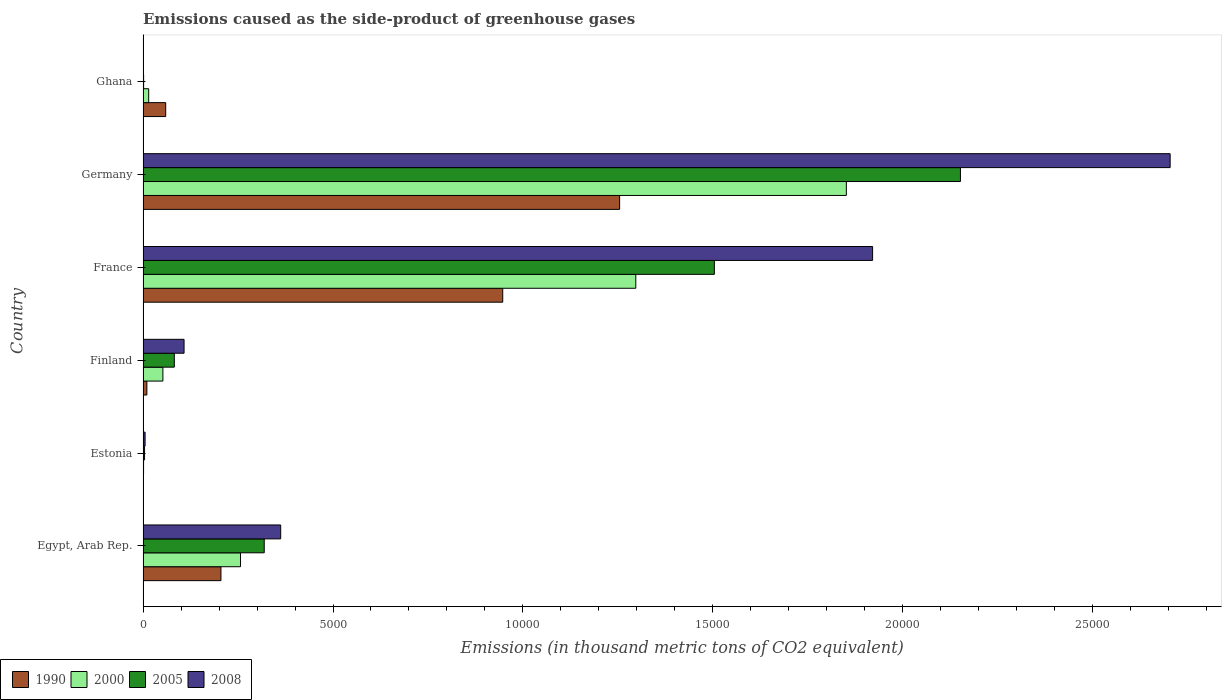Are the number of bars per tick equal to the number of legend labels?
Provide a short and direct response. Yes. How many bars are there on the 2nd tick from the bottom?
Offer a terse response. 4. In how many cases, is the number of bars for a given country not equal to the number of legend labels?
Provide a succinct answer. 0. What is the emissions caused as the side-product of greenhouse gases in 2000 in Ghana?
Your answer should be compact. 148. Across all countries, what is the maximum emissions caused as the side-product of greenhouse gases in 2000?
Your answer should be compact. 1.85e+04. Across all countries, what is the minimum emissions caused as the side-product of greenhouse gases in 1990?
Make the answer very short. 2.1. In which country was the emissions caused as the side-product of greenhouse gases in 2008 maximum?
Give a very brief answer. Germany. In which country was the emissions caused as the side-product of greenhouse gases in 2008 minimum?
Offer a terse response. Ghana. What is the total emissions caused as the side-product of greenhouse gases in 2000 in the graph?
Keep it short and to the point. 3.47e+04. What is the difference between the emissions caused as the side-product of greenhouse gases in 2005 in Estonia and that in Germany?
Offer a terse response. -2.15e+04. What is the difference between the emissions caused as the side-product of greenhouse gases in 2005 in Ghana and the emissions caused as the side-product of greenhouse gases in 2000 in France?
Your response must be concise. -1.30e+04. What is the average emissions caused as the side-product of greenhouse gases in 2008 per country?
Ensure brevity in your answer.  8501.6. What is the difference between the emissions caused as the side-product of greenhouse gases in 1990 and emissions caused as the side-product of greenhouse gases in 2000 in Germany?
Your answer should be very brief. -5968.2. What is the ratio of the emissions caused as the side-product of greenhouse gases in 2000 in Egypt, Arab Rep. to that in France?
Offer a very short reply. 0.2. Is the difference between the emissions caused as the side-product of greenhouse gases in 1990 in Finland and Ghana greater than the difference between the emissions caused as the side-product of greenhouse gases in 2000 in Finland and Ghana?
Your answer should be very brief. No. What is the difference between the highest and the second highest emissions caused as the side-product of greenhouse gases in 2008?
Your answer should be very brief. 7832.8. What is the difference between the highest and the lowest emissions caused as the side-product of greenhouse gases in 2005?
Offer a very short reply. 2.15e+04. In how many countries, is the emissions caused as the side-product of greenhouse gases in 1990 greater than the average emissions caused as the side-product of greenhouse gases in 1990 taken over all countries?
Your answer should be very brief. 2. Is the sum of the emissions caused as the side-product of greenhouse gases in 2008 in Egypt, Arab Rep. and France greater than the maximum emissions caused as the side-product of greenhouse gases in 2005 across all countries?
Your response must be concise. Yes. Is it the case that in every country, the sum of the emissions caused as the side-product of greenhouse gases in 1990 and emissions caused as the side-product of greenhouse gases in 2008 is greater than the sum of emissions caused as the side-product of greenhouse gases in 2000 and emissions caused as the side-product of greenhouse gases in 2005?
Provide a short and direct response. No. What does the 1st bar from the bottom in Ghana represents?
Offer a terse response. 1990. Is it the case that in every country, the sum of the emissions caused as the side-product of greenhouse gases in 2008 and emissions caused as the side-product of greenhouse gases in 2005 is greater than the emissions caused as the side-product of greenhouse gases in 2000?
Give a very brief answer. No. How many bars are there?
Your answer should be compact. 24. Are all the bars in the graph horizontal?
Keep it short and to the point. Yes. What is the difference between two consecutive major ticks on the X-axis?
Offer a terse response. 5000. Are the values on the major ticks of X-axis written in scientific E-notation?
Make the answer very short. No. Does the graph contain grids?
Your response must be concise. No. How many legend labels are there?
Your answer should be very brief. 4. How are the legend labels stacked?
Keep it short and to the point. Horizontal. What is the title of the graph?
Keep it short and to the point. Emissions caused as the side-product of greenhouse gases. What is the label or title of the X-axis?
Your response must be concise. Emissions (in thousand metric tons of CO2 equivalent). What is the label or title of the Y-axis?
Offer a terse response. Country. What is the Emissions (in thousand metric tons of CO2 equivalent) in 1990 in Egypt, Arab Rep.?
Your answer should be very brief. 2050.5. What is the Emissions (in thousand metric tons of CO2 equivalent) of 2000 in Egypt, Arab Rep.?
Your response must be concise. 2565.6. What is the Emissions (in thousand metric tons of CO2 equivalent) of 2005 in Egypt, Arab Rep.?
Keep it short and to the point. 3189.8. What is the Emissions (in thousand metric tons of CO2 equivalent) in 2008 in Egypt, Arab Rep.?
Ensure brevity in your answer.  3622.8. What is the Emissions (in thousand metric tons of CO2 equivalent) of 2000 in Estonia?
Your answer should be very brief. 13.3. What is the Emissions (in thousand metric tons of CO2 equivalent) in 2005 in Estonia?
Give a very brief answer. 39.4. What is the Emissions (in thousand metric tons of CO2 equivalent) of 2008 in Estonia?
Give a very brief answer. 53.3. What is the Emissions (in thousand metric tons of CO2 equivalent) in 1990 in Finland?
Give a very brief answer. 100.2. What is the Emissions (in thousand metric tons of CO2 equivalent) in 2000 in Finland?
Give a very brief answer. 521.8. What is the Emissions (in thousand metric tons of CO2 equivalent) in 2005 in Finland?
Provide a succinct answer. 822.5. What is the Emissions (in thousand metric tons of CO2 equivalent) in 2008 in Finland?
Provide a succinct answer. 1079.5. What is the Emissions (in thousand metric tons of CO2 equivalent) in 1990 in France?
Provide a succinct answer. 9468.2. What is the Emissions (in thousand metric tons of CO2 equivalent) in 2000 in France?
Keep it short and to the point. 1.30e+04. What is the Emissions (in thousand metric tons of CO2 equivalent) of 2005 in France?
Give a very brief answer. 1.50e+04. What is the Emissions (in thousand metric tons of CO2 equivalent) of 2008 in France?
Give a very brief answer. 1.92e+04. What is the Emissions (in thousand metric tons of CO2 equivalent) in 1990 in Germany?
Your answer should be compact. 1.25e+04. What is the Emissions (in thousand metric tons of CO2 equivalent) of 2000 in Germany?
Give a very brief answer. 1.85e+04. What is the Emissions (in thousand metric tons of CO2 equivalent) in 2005 in Germany?
Keep it short and to the point. 2.15e+04. What is the Emissions (in thousand metric tons of CO2 equivalent) of 2008 in Germany?
Keep it short and to the point. 2.70e+04. What is the Emissions (in thousand metric tons of CO2 equivalent) in 1990 in Ghana?
Provide a short and direct response. 596.2. What is the Emissions (in thousand metric tons of CO2 equivalent) of 2000 in Ghana?
Keep it short and to the point. 148. What is the Emissions (in thousand metric tons of CO2 equivalent) of 2008 in Ghana?
Offer a very short reply. 11.2. Across all countries, what is the maximum Emissions (in thousand metric tons of CO2 equivalent) in 1990?
Make the answer very short. 1.25e+04. Across all countries, what is the maximum Emissions (in thousand metric tons of CO2 equivalent) of 2000?
Keep it short and to the point. 1.85e+04. Across all countries, what is the maximum Emissions (in thousand metric tons of CO2 equivalent) of 2005?
Keep it short and to the point. 2.15e+04. Across all countries, what is the maximum Emissions (in thousand metric tons of CO2 equivalent) in 2008?
Keep it short and to the point. 2.70e+04. Across all countries, what is the minimum Emissions (in thousand metric tons of CO2 equivalent) of 2000?
Your answer should be very brief. 13.3. Across all countries, what is the minimum Emissions (in thousand metric tons of CO2 equivalent) of 2005?
Give a very brief answer. 14.7. Across all countries, what is the minimum Emissions (in thousand metric tons of CO2 equivalent) of 2008?
Give a very brief answer. 11.2. What is the total Emissions (in thousand metric tons of CO2 equivalent) in 1990 in the graph?
Offer a terse response. 2.48e+04. What is the total Emissions (in thousand metric tons of CO2 equivalent) in 2000 in the graph?
Offer a terse response. 3.47e+04. What is the total Emissions (in thousand metric tons of CO2 equivalent) in 2005 in the graph?
Offer a terse response. 4.06e+04. What is the total Emissions (in thousand metric tons of CO2 equivalent) in 2008 in the graph?
Your response must be concise. 5.10e+04. What is the difference between the Emissions (in thousand metric tons of CO2 equivalent) of 1990 in Egypt, Arab Rep. and that in Estonia?
Provide a succinct answer. 2048.4. What is the difference between the Emissions (in thousand metric tons of CO2 equivalent) of 2000 in Egypt, Arab Rep. and that in Estonia?
Provide a short and direct response. 2552.3. What is the difference between the Emissions (in thousand metric tons of CO2 equivalent) in 2005 in Egypt, Arab Rep. and that in Estonia?
Keep it short and to the point. 3150.4. What is the difference between the Emissions (in thousand metric tons of CO2 equivalent) of 2008 in Egypt, Arab Rep. and that in Estonia?
Your answer should be very brief. 3569.5. What is the difference between the Emissions (in thousand metric tons of CO2 equivalent) in 1990 in Egypt, Arab Rep. and that in Finland?
Offer a very short reply. 1950.3. What is the difference between the Emissions (in thousand metric tons of CO2 equivalent) of 2000 in Egypt, Arab Rep. and that in Finland?
Give a very brief answer. 2043.8. What is the difference between the Emissions (in thousand metric tons of CO2 equivalent) of 2005 in Egypt, Arab Rep. and that in Finland?
Your answer should be very brief. 2367.3. What is the difference between the Emissions (in thousand metric tons of CO2 equivalent) in 2008 in Egypt, Arab Rep. and that in Finland?
Ensure brevity in your answer.  2543.3. What is the difference between the Emissions (in thousand metric tons of CO2 equivalent) of 1990 in Egypt, Arab Rep. and that in France?
Provide a short and direct response. -7417.7. What is the difference between the Emissions (in thousand metric tons of CO2 equivalent) in 2000 in Egypt, Arab Rep. and that in France?
Your answer should be very brief. -1.04e+04. What is the difference between the Emissions (in thousand metric tons of CO2 equivalent) of 2005 in Egypt, Arab Rep. and that in France?
Provide a short and direct response. -1.18e+04. What is the difference between the Emissions (in thousand metric tons of CO2 equivalent) in 2008 in Egypt, Arab Rep. and that in France?
Offer a very short reply. -1.56e+04. What is the difference between the Emissions (in thousand metric tons of CO2 equivalent) of 1990 in Egypt, Arab Rep. and that in Germany?
Offer a terse response. -1.05e+04. What is the difference between the Emissions (in thousand metric tons of CO2 equivalent) in 2000 in Egypt, Arab Rep. and that in Germany?
Offer a very short reply. -1.59e+04. What is the difference between the Emissions (in thousand metric tons of CO2 equivalent) in 2005 in Egypt, Arab Rep. and that in Germany?
Your answer should be very brief. -1.83e+04. What is the difference between the Emissions (in thousand metric tons of CO2 equivalent) of 2008 in Egypt, Arab Rep. and that in Germany?
Give a very brief answer. -2.34e+04. What is the difference between the Emissions (in thousand metric tons of CO2 equivalent) in 1990 in Egypt, Arab Rep. and that in Ghana?
Keep it short and to the point. 1454.3. What is the difference between the Emissions (in thousand metric tons of CO2 equivalent) in 2000 in Egypt, Arab Rep. and that in Ghana?
Your response must be concise. 2417.6. What is the difference between the Emissions (in thousand metric tons of CO2 equivalent) of 2005 in Egypt, Arab Rep. and that in Ghana?
Provide a short and direct response. 3175.1. What is the difference between the Emissions (in thousand metric tons of CO2 equivalent) in 2008 in Egypt, Arab Rep. and that in Ghana?
Your answer should be very brief. 3611.6. What is the difference between the Emissions (in thousand metric tons of CO2 equivalent) in 1990 in Estonia and that in Finland?
Ensure brevity in your answer.  -98.1. What is the difference between the Emissions (in thousand metric tons of CO2 equivalent) in 2000 in Estonia and that in Finland?
Ensure brevity in your answer.  -508.5. What is the difference between the Emissions (in thousand metric tons of CO2 equivalent) in 2005 in Estonia and that in Finland?
Offer a terse response. -783.1. What is the difference between the Emissions (in thousand metric tons of CO2 equivalent) of 2008 in Estonia and that in Finland?
Ensure brevity in your answer.  -1026.2. What is the difference between the Emissions (in thousand metric tons of CO2 equivalent) in 1990 in Estonia and that in France?
Give a very brief answer. -9466.1. What is the difference between the Emissions (in thousand metric tons of CO2 equivalent) of 2000 in Estonia and that in France?
Make the answer very short. -1.30e+04. What is the difference between the Emissions (in thousand metric tons of CO2 equivalent) of 2005 in Estonia and that in France?
Offer a terse response. -1.50e+04. What is the difference between the Emissions (in thousand metric tons of CO2 equivalent) of 2008 in Estonia and that in France?
Offer a terse response. -1.92e+04. What is the difference between the Emissions (in thousand metric tons of CO2 equivalent) in 1990 in Estonia and that in Germany?
Keep it short and to the point. -1.25e+04. What is the difference between the Emissions (in thousand metric tons of CO2 equivalent) in 2000 in Estonia and that in Germany?
Offer a very short reply. -1.85e+04. What is the difference between the Emissions (in thousand metric tons of CO2 equivalent) of 2005 in Estonia and that in Germany?
Your answer should be compact. -2.15e+04. What is the difference between the Emissions (in thousand metric tons of CO2 equivalent) in 2008 in Estonia and that in Germany?
Ensure brevity in your answer.  -2.70e+04. What is the difference between the Emissions (in thousand metric tons of CO2 equivalent) of 1990 in Estonia and that in Ghana?
Provide a succinct answer. -594.1. What is the difference between the Emissions (in thousand metric tons of CO2 equivalent) in 2000 in Estonia and that in Ghana?
Offer a terse response. -134.7. What is the difference between the Emissions (in thousand metric tons of CO2 equivalent) of 2005 in Estonia and that in Ghana?
Make the answer very short. 24.7. What is the difference between the Emissions (in thousand metric tons of CO2 equivalent) of 2008 in Estonia and that in Ghana?
Ensure brevity in your answer.  42.1. What is the difference between the Emissions (in thousand metric tons of CO2 equivalent) in 1990 in Finland and that in France?
Provide a short and direct response. -9368. What is the difference between the Emissions (in thousand metric tons of CO2 equivalent) of 2000 in Finland and that in France?
Make the answer very short. -1.24e+04. What is the difference between the Emissions (in thousand metric tons of CO2 equivalent) of 2005 in Finland and that in France?
Keep it short and to the point. -1.42e+04. What is the difference between the Emissions (in thousand metric tons of CO2 equivalent) in 2008 in Finland and that in France?
Offer a terse response. -1.81e+04. What is the difference between the Emissions (in thousand metric tons of CO2 equivalent) in 1990 in Finland and that in Germany?
Provide a succinct answer. -1.24e+04. What is the difference between the Emissions (in thousand metric tons of CO2 equivalent) of 2000 in Finland and that in Germany?
Keep it short and to the point. -1.80e+04. What is the difference between the Emissions (in thousand metric tons of CO2 equivalent) in 2005 in Finland and that in Germany?
Provide a short and direct response. -2.07e+04. What is the difference between the Emissions (in thousand metric tons of CO2 equivalent) of 2008 in Finland and that in Germany?
Your answer should be very brief. -2.60e+04. What is the difference between the Emissions (in thousand metric tons of CO2 equivalent) of 1990 in Finland and that in Ghana?
Make the answer very short. -496. What is the difference between the Emissions (in thousand metric tons of CO2 equivalent) in 2000 in Finland and that in Ghana?
Make the answer very short. 373.8. What is the difference between the Emissions (in thousand metric tons of CO2 equivalent) of 2005 in Finland and that in Ghana?
Offer a terse response. 807.8. What is the difference between the Emissions (in thousand metric tons of CO2 equivalent) in 2008 in Finland and that in Ghana?
Provide a succinct answer. 1068.3. What is the difference between the Emissions (in thousand metric tons of CO2 equivalent) of 1990 in France and that in Germany?
Keep it short and to the point. -3077.5. What is the difference between the Emissions (in thousand metric tons of CO2 equivalent) in 2000 in France and that in Germany?
Your answer should be very brief. -5542.7. What is the difference between the Emissions (in thousand metric tons of CO2 equivalent) in 2005 in France and that in Germany?
Your response must be concise. -6478.3. What is the difference between the Emissions (in thousand metric tons of CO2 equivalent) of 2008 in France and that in Germany?
Provide a short and direct response. -7832.8. What is the difference between the Emissions (in thousand metric tons of CO2 equivalent) of 1990 in France and that in Ghana?
Provide a succinct answer. 8872. What is the difference between the Emissions (in thousand metric tons of CO2 equivalent) in 2000 in France and that in Ghana?
Make the answer very short. 1.28e+04. What is the difference between the Emissions (in thousand metric tons of CO2 equivalent) in 2005 in France and that in Ghana?
Your response must be concise. 1.50e+04. What is the difference between the Emissions (in thousand metric tons of CO2 equivalent) in 2008 in France and that in Ghana?
Give a very brief answer. 1.92e+04. What is the difference between the Emissions (in thousand metric tons of CO2 equivalent) in 1990 in Germany and that in Ghana?
Provide a succinct answer. 1.19e+04. What is the difference between the Emissions (in thousand metric tons of CO2 equivalent) in 2000 in Germany and that in Ghana?
Keep it short and to the point. 1.84e+04. What is the difference between the Emissions (in thousand metric tons of CO2 equivalent) of 2005 in Germany and that in Ghana?
Give a very brief answer. 2.15e+04. What is the difference between the Emissions (in thousand metric tons of CO2 equivalent) in 2008 in Germany and that in Ghana?
Offer a very short reply. 2.70e+04. What is the difference between the Emissions (in thousand metric tons of CO2 equivalent) of 1990 in Egypt, Arab Rep. and the Emissions (in thousand metric tons of CO2 equivalent) of 2000 in Estonia?
Keep it short and to the point. 2037.2. What is the difference between the Emissions (in thousand metric tons of CO2 equivalent) in 1990 in Egypt, Arab Rep. and the Emissions (in thousand metric tons of CO2 equivalent) in 2005 in Estonia?
Give a very brief answer. 2011.1. What is the difference between the Emissions (in thousand metric tons of CO2 equivalent) of 1990 in Egypt, Arab Rep. and the Emissions (in thousand metric tons of CO2 equivalent) of 2008 in Estonia?
Your response must be concise. 1997.2. What is the difference between the Emissions (in thousand metric tons of CO2 equivalent) in 2000 in Egypt, Arab Rep. and the Emissions (in thousand metric tons of CO2 equivalent) in 2005 in Estonia?
Keep it short and to the point. 2526.2. What is the difference between the Emissions (in thousand metric tons of CO2 equivalent) of 2000 in Egypt, Arab Rep. and the Emissions (in thousand metric tons of CO2 equivalent) of 2008 in Estonia?
Your response must be concise. 2512.3. What is the difference between the Emissions (in thousand metric tons of CO2 equivalent) of 2005 in Egypt, Arab Rep. and the Emissions (in thousand metric tons of CO2 equivalent) of 2008 in Estonia?
Ensure brevity in your answer.  3136.5. What is the difference between the Emissions (in thousand metric tons of CO2 equivalent) in 1990 in Egypt, Arab Rep. and the Emissions (in thousand metric tons of CO2 equivalent) in 2000 in Finland?
Provide a succinct answer. 1528.7. What is the difference between the Emissions (in thousand metric tons of CO2 equivalent) in 1990 in Egypt, Arab Rep. and the Emissions (in thousand metric tons of CO2 equivalent) in 2005 in Finland?
Keep it short and to the point. 1228. What is the difference between the Emissions (in thousand metric tons of CO2 equivalent) in 1990 in Egypt, Arab Rep. and the Emissions (in thousand metric tons of CO2 equivalent) in 2008 in Finland?
Ensure brevity in your answer.  971. What is the difference between the Emissions (in thousand metric tons of CO2 equivalent) in 2000 in Egypt, Arab Rep. and the Emissions (in thousand metric tons of CO2 equivalent) in 2005 in Finland?
Make the answer very short. 1743.1. What is the difference between the Emissions (in thousand metric tons of CO2 equivalent) of 2000 in Egypt, Arab Rep. and the Emissions (in thousand metric tons of CO2 equivalent) of 2008 in Finland?
Your answer should be compact. 1486.1. What is the difference between the Emissions (in thousand metric tons of CO2 equivalent) in 2005 in Egypt, Arab Rep. and the Emissions (in thousand metric tons of CO2 equivalent) in 2008 in Finland?
Provide a short and direct response. 2110.3. What is the difference between the Emissions (in thousand metric tons of CO2 equivalent) of 1990 in Egypt, Arab Rep. and the Emissions (in thousand metric tons of CO2 equivalent) of 2000 in France?
Make the answer very short. -1.09e+04. What is the difference between the Emissions (in thousand metric tons of CO2 equivalent) in 1990 in Egypt, Arab Rep. and the Emissions (in thousand metric tons of CO2 equivalent) in 2005 in France?
Provide a succinct answer. -1.30e+04. What is the difference between the Emissions (in thousand metric tons of CO2 equivalent) of 1990 in Egypt, Arab Rep. and the Emissions (in thousand metric tons of CO2 equivalent) of 2008 in France?
Ensure brevity in your answer.  -1.72e+04. What is the difference between the Emissions (in thousand metric tons of CO2 equivalent) of 2000 in Egypt, Arab Rep. and the Emissions (in thousand metric tons of CO2 equivalent) of 2005 in France?
Your answer should be compact. -1.25e+04. What is the difference between the Emissions (in thousand metric tons of CO2 equivalent) of 2000 in Egypt, Arab Rep. and the Emissions (in thousand metric tons of CO2 equivalent) of 2008 in France?
Offer a very short reply. -1.66e+04. What is the difference between the Emissions (in thousand metric tons of CO2 equivalent) of 2005 in Egypt, Arab Rep. and the Emissions (in thousand metric tons of CO2 equivalent) of 2008 in France?
Keep it short and to the point. -1.60e+04. What is the difference between the Emissions (in thousand metric tons of CO2 equivalent) of 1990 in Egypt, Arab Rep. and the Emissions (in thousand metric tons of CO2 equivalent) of 2000 in Germany?
Give a very brief answer. -1.65e+04. What is the difference between the Emissions (in thousand metric tons of CO2 equivalent) in 1990 in Egypt, Arab Rep. and the Emissions (in thousand metric tons of CO2 equivalent) in 2005 in Germany?
Your response must be concise. -1.95e+04. What is the difference between the Emissions (in thousand metric tons of CO2 equivalent) in 1990 in Egypt, Arab Rep. and the Emissions (in thousand metric tons of CO2 equivalent) in 2008 in Germany?
Offer a very short reply. -2.50e+04. What is the difference between the Emissions (in thousand metric tons of CO2 equivalent) of 2000 in Egypt, Arab Rep. and the Emissions (in thousand metric tons of CO2 equivalent) of 2005 in Germany?
Ensure brevity in your answer.  -1.90e+04. What is the difference between the Emissions (in thousand metric tons of CO2 equivalent) of 2000 in Egypt, Arab Rep. and the Emissions (in thousand metric tons of CO2 equivalent) of 2008 in Germany?
Your answer should be compact. -2.45e+04. What is the difference between the Emissions (in thousand metric tons of CO2 equivalent) of 2005 in Egypt, Arab Rep. and the Emissions (in thousand metric tons of CO2 equivalent) of 2008 in Germany?
Make the answer very short. -2.38e+04. What is the difference between the Emissions (in thousand metric tons of CO2 equivalent) in 1990 in Egypt, Arab Rep. and the Emissions (in thousand metric tons of CO2 equivalent) in 2000 in Ghana?
Make the answer very short. 1902.5. What is the difference between the Emissions (in thousand metric tons of CO2 equivalent) of 1990 in Egypt, Arab Rep. and the Emissions (in thousand metric tons of CO2 equivalent) of 2005 in Ghana?
Your answer should be compact. 2035.8. What is the difference between the Emissions (in thousand metric tons of CO2 equivalent) of 1990 in Egypt, Arab Rep. and the Emissions (in thousand metric tons of CO2 equivalent) of 2008 in Ghana?
Provide a succinct answer. 2039.3. What is the difference between the Emissions (in thousand metric tons of CO2 equivalent) of 2000 in Egypt, Arab Rep. and the Emissions (in thousand metric tons of CO2 equivalent) of 2005 in Ghana?
Your answer should be compact. 2550.9. What is the difference between the Emissions (in thousand metric tons of CO2 equivalent) in 2000 in Egypt, Arab Rep. and the Emissions (in thousand metric tons of CO2 equivalent) in 2008 in Ghana?
Provide a short and direct response. 2554.4. What is the difference between the Emissions (in thousand metric tons of CO2 equivalent) in 2005 in Egypt, Arab Rep. and the Emissions (in thousand metric tons of CO2 equivalent) in 2008 in Ghana?
Your response must be concise. 3178.6. What is the difference between the Emissions (in thousand metric tons of CO2 equivalent) in 1990 in Estonia and the Emissions (in thousand metric tons of CO2 equivalent) in 2000 in Finland?
Your response must be concise. -519.7. What is the difference between the Emissions (in thousand metric tons of CO2 equivalent) of 1990 in Estonia and the Emissions (in thousand metric tons of CO2 equivalent) of 2005 in Finland?
Make the answer very short. -820.4. What is the difference between the Emissions (in thousand metric tons of CO2 equivalent) of 1990 in Estonia and the Emissions (in thousand metric tons of CO2 equivalent) of 2008 in Finland?
Provide a short and direct response. -1077.4. What is the difference between the Emissions (in thousand metric tons of CO2 equivalent) in 2000 in Estonia and the Emissions (in thousand metric tons of CO2 equivalent) in 2005 in Finland?
Offer a terse response. -809.2. What is the difference between the Emissions (in thousand metric tons of CO2 equivalent) in 2000 in Estonia and the Emissions (in thousand metric tons of CO2 equivalent) in 2008 in Finland?
Make the answer very short. -1066.2. What is the difference between the Emissions (in thousand metric tons of CO2 equivalent) of 2005 in Estonia and the Emissions (in thousand metric tons of CO2 equivalent) of 2008 in Finland?
Offer a very short reply. -1040.1. What is the difference between the Emissions (in thousand metric tons of CO2 equivalent) in 1990 in Estonia and the Emissions (in thousand metric tons of CO2 equivalent) in 2000 in France?
Make the answer very short. -1.30e+04. What is the difference between the Emissions (in thousand metric tons of CO2 equivalent) in 1990 in Estonia and the Emissions (in thousand metric tons of CO2 equivalent) in 2005 in France?
Keep it short and to the point. -1.50e+04. What is the difference between the Emissions (in thousand metric tons of CO2 equivalent) of 1990 in Estonia and the Emissions (in thousand metric tons of CO2 equivalent) of 2008 in France?
Offer a terse response. -1.92e+04. What is the difference between the Emissions (in thousand metric tons of CO2 equivalent) in 2000 in Estonia and the Emissions (in thousand metric tons of CO2 equivalent) in 2005 in France?
Your answer should be very brief. -1.50e+04. What is the difference between the Emissions (in thousand metric tons of CO2 equivalent) in 2000 in Estonia and the Emissions (in thousand metric tons of CO2 equivalent) in 2008 in France?
Give a very brief answer. -1.92e+04. What is the difference between the Emissions (in thousand metric tons of CO2 equivalent) in 2005 in Estonia and the Emissions (in thousand metric tons of CO2 equivalent) in 2008 in France?
Provide a short and direct response. -1.92e+04. What is the difference between the Emissions (in thousand metric tons of CO2 equivalent) of 1990 in Estonia and the Emissions (in thousand metric tons of CO2 equivalent) of 2000 in Germany?
Keep it short and to the point. -1.85e+04. What is the difference between the Emissions (in thousand metric tons of CO2 equivalent) in 1990 in Estonia and the Emissions (in thousand metric tons of CO2 equivalent) in 2005 in Germany?
Make the answer very short. -2.15e+04. What is the difference between the Emissions (in thousand metric tons of CO2 equivalent) of 1990 in Estonia and the Emissions (in thousand metric tons of CO2 equivalent) of 2008 in Germany?
Your answer should be very brief. -2.70e+04. What is the difference between the Emissions (in thousand metric tons of CO2 equivalent) of 2000 in Estonia and the Emissions (in thousand metric tons of CO2 equivalent) of 2005 in Germany?
Provide a short and direct response. -2.15e+04. What is the difference between the Emissions (in thousand metric tons of CO2 equivalent) in 2000 in Estonia and the Emissions (in thousand metric tons of CO2 equivalent) in 2008 in Germany?
Offer a terse response. -2.70e+04. What is the difference between the Emissions (in thousand metric tons of CO2 equivalent) in 2005 in Estonia and the Emissions (in thousand metric tons of CO2 equivalent) in 2008 in Germany?
Your answer should be very brief. -2.70e+04. What is the difference between the Emissions (in thousand metric tons of CO2 equivalent) of 1990 in Estonia and the Emissions (in thousand metric tons of CO2 equivalent) of 2000 in Ghana?
Ensure brevity in your answer.  -145.9. What is the difference between the Emissions (in thousand metric tons of CO2 equivalent) of 2000 in Estonia and the Emissions (in thousand metric tons of CO2 equivalent) of 2005 in Ghana?
Offer a very short reply. -1.4. What is the difference between the Emissions (in thousand metric tons of CO2 equivalent) of 2005 in Estonia and the Emissions (in thousand metric tons of CO2 equivalent) of 2008 in Ghana?
Offer a terse response. 28.2. What is the difference between the Emissions (in thousand metric tons of CO2 equivalent) of 1990 in Finland and the Emissions (in thousand metric tons of CO2 equivalent) of 2000 in France?
Make the answer very short. -1.29e+04. What is the difference between the Emissions (in thousand metric tons of CO2 equivalent) of 1990 in Finland and the Emissions (in thousand metric tons of CO2 equivalent) of 2005 in France?
Your answer should be very brief. -1.49e+04. What is the difference between the Emissions (in thousand metric tons of CO2 equivalent) of 1990 in Finland and the Emissions (in thousand metric tons of CO2 equivalent) of 2008 in France?
Provide a short and direct response. -1.91e+04. What is the difference between the Emissions (in thousand metric tons of CO2 equivalent) of 2000 in Finland and the Emissions (in thousand metric tons of CO2 equivalent) of 2005 in France?
Your response must be concise. -1.45e+04. What is the difference between the Emissions (in thousand metric tons of CO2 equivalent) of 2000 in Finland and the Emissions (in thousand metric tons of CO2 equivalent) of 2008 in France?
Offer a terse response. -1.87e+04. What is the difference between the Emissions (in thousand metric tons of CO2 equivalent) of 2005 in Finland and the Emissions (in thousand metric tons of CO2 equivalent) of 2008 in France?
Give a very brief answer. -1.84e+04. What is the difference between the Emissions (in thousand metric tons of CO2 equivalent) of 1990 in Finland and the Emissions (in thousand metric tons of CO2 equivalent) of 2000 in Germany?
Your response must be concise. -1.84e+04. What is the difference between the Emissions (in thousand metric tons of CO2 equivalent) of 1990 in Finland and the Emissions (in thousand metric tons of CO2 equivalent) of 2005 in Germany?
Your response must be concise. -2.14e+04. What is the difference between the Emissions (in thousand metric tons of CO2 equivalent) in 1990 in Finland and the Emissions (in thousand metric tons of CO2 equivalent) in 2008 in Germany?
Give a very brief answer. -2.69e+04. What is the difference between the Emissions (in thousand metric tons of CO2 equivalent) in 2000 in Finland and the Emissions (in thousand metric tons of CO2 equivalent) in 2005 in Germany?
Offer a very short reply. -2.10e+04. What is the difference between the Emissions (in thousand metric tons of CO2 equivalent) of 2000 in Finland and the Emissions (in thousand metric tons of CO2 equivalent) of 2008 in Germany?
Make the answer very short. -2.65e+04. What is the difference between the Emissions (in thousand metric tons of CO2 equivalent) in 2005 in Finland and the Emissions (in thousand metric tons of CO2 equivalent) in 2008 in Germany?
Make the answer very short. -2.62e+04. What is the difference between the Emissions (in thousand metric tons of CO2 equivalent) of 1990 in Finland and the Emissions (in thousand metric tons of CO2 equivalent) of 2000 in Ghana?
Ensure brevity in your answer.  -47.8. What is the difference between the Emissions (in thousand metric tons of CO2 equivalent) in 1990 in Finland and the Emissions (in thousand metric tons of CO2 equivalent) in 2005 in Ghana?
Your answer should be very brief. 85.5. What is the difference between the Emissions (in thousand metric tons of CO2 equivalent) in 1990 in Finland and the Emissions (in thousand metric tons of CO2 equivalent) in 2008 in Ghana?
Ensure brevity in your answer.  89. What is the difference between the Emissions (in thousand metric tons of CO2 equivalent) in 2000 in Finland and the Emissions (in thousand metric tons of CO2 equivalent) in 2005 in Ghana?
Provide a succinct answer. 507.1. What is the difference between the Emissions (in thousand metric tons of CO2 equivalent) in 2000 in Finland and the Emissions (in thousand metric tons of CO2 equivalent) in 2008 in Ghana?
Give a very brief answer. 510.6. What is the difference between the Emissions (in thousand metric tons of CO2 equivalent) of 2005 in Finland and the Emissions (in thousand metric tons of CO2 equivalent) of 2008 in Ghana?
Offer a terse response. 811.3. What is the difference between the Emissions (in thousand metric tons of CO2 equivalent) of 1990 in France and the Emissions (in thousand metric tons of CO2 equivalent) of 2000 in Germany?
Make the answer very short. -9045.7. What is the difference between the Emissions (in thousand metric tons of CO2 equivalent) of 1990 in France and the Emissions (in thousand metric tons of CO2 equivalent) of 2005 in Germany?
Your answer should be compact. -1.20e+04. What is the difference between the Emissions (in thousand metric tons of CO2 equivalent) in 1990 in France and the Emissions (in thousand metric tons of CO2 equivalent) in 2008 in Germany?
Offer a terse response. -1.76e+04. What is the difference between the Emissions (in thousand metric tons of CO2 equivalent) in 2000 in France and the Emissions (in thousand metric tons of CO2 equivalent) in 2005 in Germany?
Keep it short and to the point. -8546.3. What is the difference between the Emissions (in thousand metric tons of CO2 equivalent) of 2000 in France and the Emissions (in thousand metric tons of CO2 equivalent) of 2008 in Germany?
Offer a very short reply. -1.41e+04. What is the difference between the Emissions (in thousand metric tons of CO2 equivalent) in 2005 in France and the Emissions (in thousand metric tons of CO2 equivalent) in 2008 in Germany?
Provide a succinct answer. -1.20e+04. What is the difference between the Emissions (in thousand metric tons of CO2 equivalent) of 1990 in France and the Emissions (in thousand metric tons of CO2 equivalent) of 2000 in Ghana?
Make the answer very short. 9320.2. What is the difference between the Emissions (in thousand metric tons of CO2 equivalent) in 1990 in France and the Emissions (in thousand metric tons of CO2 equivalent) in 2005 in Ghana?
Keep it short and to the point. 9453.5. What is the difference between the Emissions (in thousand metric tons of CO2 equivalent) in 1990 in France and the Emissions (in thousand metric tons of CO2 equivalent) in 2008 in Ghana?
Offer a very short reply. 9457. What is the difference between the Emissions (in thousand metric tons of CO2 equivalent) of 2000 in France and the Emissions (in thousand metric tons of CO2 equivalent) of 2005 in Ghana?
Ensure brevity in your answer.  1.30e+04. What is the difference between the Emissions (in thousand metric tons of CO2 equivalent) in 2000 in France and the Emissions (in thousand metric tons of CO2 equivalent) in 2008 in Ghana?
Keep it short and to the point. 1.30e+04. What is the difference between the Emissions (in thousand metric tons of CO2 equivalent) in 2005 in France and the Emissions (in thousand metric tons of CO2 equivalent) in 2008 in Ghana?
Offer a terse response. 1.50e+04. What is the difference between the Emissions (in thousand metric tons of CO2 equivalent) in 1990 in Germany and the Emissions (in thousand metric tons of CO2 equivalent) in 2000 in Ghana?
Offer a terse response. 1.24e+04. What is the difference between the Emissions (in thousand metric tons of CO2 equivalent) of 1990 in Germany and the Emissions (in thousand metric tons of CO2 equivalent) of 2005 in Ghana?
Offer a very short reply. 1.25e+04. What is the difference between the Emissions (in thousand metric tons of CO2 equivalent) of 1990 in Germany and the Emissions (in thousand metric tons of CO2 equivalent) of 2008 in Ghana?
Offer a terse response. 1.25e+04. What is the difference between the Emissions (in thousand metric tons of CO2 equivalent) in 2000 in Germany and the Emissions (in thousand metric tons of CO2 equivalent) in 2005 in Ghana?
Offer a very short reply. 1.85e+04. What is the difference between the Emissions (in thousand metric tons of CO2 equivalent) of 2000 in Germany and the Emissions (in thousand metric tons of CO2 equivalent) of 2008 in Ghana?
Provide a succinct answer. 1.85e+04. What is the difference between the Emissions (in thousand metric tons of CO2 equivalent) in 2005 in Germany and the Emissions (in thousand metric tons of CO2 equivalent) in 2008 in Ghana?
Offer a very short reply. 2.15e+04. What is the average Emissions (in thousand metric tons of CO2 equivalent) in 1990 per country?
Keep it short and to the point. 4127.15. What is the average Emissions (in thousand metric tons of CO2 equivalent) in 2000 per country?
Your response must be concise. 5788.97. What is the average Emissions (in thousand metric tons of CO2 equivalent) of 2005 per country?
Provide a short and direct response. 6770.52. What is the average Emissions (in thousand metric tons of CO2 equivalent) in 2008 per country?
Make the answer very short. 8501.6. What is the difference between the Emissions (in thousand metric tons of CO2 equivalent) in 1990 and Emissions (in thousand metric tons of CO2 equivalent) in 2000 in Egypt, Arab Rep.?
Your answer should be compact. -515.1. What is the difference between the Emissions (in thousand metric tons of CO2 equivalent) in 1990 and Emissions (in thousand metric tons of CO2 equivalent) in 2005 in Egypt, Arab Rep.?
Offer a very short reply. -1139.3. What is the difference between the Emissions (in thousand metric tons of CO2 equivalent) in 1990 and Emissions (in thousand metric tons of CO2 equivalent) in 2008 in Egypt, Arab Rep.?
Your response must be concise. -1572.3. What is the difference between the Emissions (in thousand metric tons of CO2 equivalent) in 2000 and Emissions (in thousand metric tons of CO2 equivalent) in 2005 in Egypt, Arab Rep.?
Your answer should be compact. -624.2. What is the difference between the Emissions (in thousand metric tons of CO2 equivalent) in 2000 and Emissions (in thousand metric tons of CO2 equivalent) in 2008 in Egypt, Arab Rep.?
Your answer should be very brief. -1057.2. What is the difference between the Emissions (in thousand metric tons of CO2 equivalent) in 2005 and Emissions (in thousand metric tons of CO2 equivalent) in 2008 in Egypt, Arab Rep.?
Provide a short and direct response. -433. What is the difference between the Emissions (in thousand metric tons of CO2 equivalent) of 1990 and Emissions (in thousand metric tons of CO2 equivalent) of 2005 in Estonia?
Provide a short and direct response. -37.3. What is the difference between the Emissions (in thousand metric tons of CO2 equivalent) of 1990 and Emissions (in thousand metric tons of CO2 equivalent) of 2008 in Estonia?
Give a very brief answer. -51.2. What is the difference between the Emissions (in thousand metric tons of CO2 equivalent) of 2000 and Emissions (in thousand metric tons of CO2 equivalent) of 2005 in Estonia?
Provide a succinct answer. -26.1. What is the difference between the Emissions (in thousand metric tons of CO2 equivalent) in 2000 and Emissions (in thousand metric tons of CO2 equivalent) in 2008 in Estonia?
Provide a short and direct response. -40. What is the difference between the Emissions (in thousand metric tons of CO2 equivalent) in 2005 and Emissions (in thousand metric tons of CO2 equivalent) in 2008 in Estonia?
Keep it short and to the point. -13.9. What is the difference between the Emissions (in thousand metric tons of CO2 equivalent) in 1990 and Emissions (in thousand metric tons of CO2 equivalent) in 2000 in Finland?
Give a very brief answer. -421.6. What is the difference between the Emissions (in thousand metric tons of CO2 equivalent) in 1990 and Emissions (in thousand metric tons of CO2 equivalent) in 2005 in Finland?
Provide a short and direct response. -722.3. What is the difference between the Emissions (in thousand metric tons of CO2 equivalent) of 1990 and Emissions (in thousand metric tons of CO2 equivalent) of 2008 in Finland?
Provide a succinct answer. -979.3. What is the difference between the Emissions (in thousand metric tons of CO2 equivalent) of 2000 and Emissions (in thousand metric tons of CO2 equivalent) of 2005 in Finland?
Your answer should be compact. -300.7. What is the difference between the Emissions (in thousand metric tons of CO2 equivalent) in 2000 and Emissions (in thousand metric tons of CO2 equivalent) in 2008 in Finland?
Your response must be concise. -557.7. What is the difference between the Emissions (in thousand metric tons of CO2 equivalent) in 2005 and Emissions (in thousand metric tons of CO2 equivalent) in 2008 in Finland?
Ensure brevity in your answer.  -257. What is the difference between the Emissions (in thousand metric tons of CO2 equivalent) in 1990 and Emissions (in thousand metric tons of CO2 equivalent) in 2000 in France?
Your answer should be very brief. -3503. What is the difference between the Emissions (in thousand metric tons of CO2 equivalent) in 1990 and Emissions (in thousand metric tons of CO2 equivalent) in 2005 in France?
Keep it short and to the point. -5571. What is the difference between the Emissions (in thousand metric tons of CO2 equivalent) in 1990 and Emissions (in thousand metric tons of CO2 equivalent) in 2008 in France?
Ensure brevity in your answer.  -9736.8. What is the difference between the Emissions (in thousand metric tons of CO2 equivalent) in 2000 and Emissions (in thousand metric tons of CO2 equivalent) in 2005 in France?
Keep it short and to the point. -2068. What is the difference between the Emissions (in thousand metric tons of CO2 equivalent) of 2000 and Emissions (in thousand metric tons of CO2 equivalent) of 2008 in France?
Give a very brief answer. -6233.8. What is the difference between the Emissions (in thousand metric tons of CO2 equivalent) in 2005 and Emissions (in thousand metric tons of CO2 equivalent) in 2008 in France?
Make the answer very short. -4165.8. What is the difference between the Emissions (in thousand metric tons of CO2 equivalent) of 1990 and Emissions (in thousand metric tons of CO2 equivalent) of 2000 in Germany?
Give a very brief answer. -5968.2. What is the difference between the Emissions (in thousand metric tons of CO2 equivalent) of 1990 and Emissions (in thousand metric tons of CO2 equivalent) of 2005 in Germany?
Ensure brevity in your answer.  -8971.8. What is the difference between the Emissions (in thousand metric tons of CO2 equivalent) in 1990 and Emissions (in thousand metric tons of CO2 equivalent) in 2008 in Germany?
Provide a succinct answer. -1.45e+04. What is the difference between the Emissions (in thousand metric tons of CO2 equivalent) in 2000 and Emissions (in thousand metric tons of CO2 equivalent) in 2005 in Germany?
Provide a short and direct response. -3003.6. What is the difference between the Emissions (in thousand metric tons of CO2 equivalent) of 2000 and Emissions (in thousand metric tons of CO2 equivalent) of 2008 in Germany?
Offer a very short reply. -8523.9. What is the difference between the Emissions (in thousand metric tons of CO2 equivalent) of 2005 and Emissions (in thousand metric tons of CO2 equivalent) of 2008 in Germany?
Provide a succinct answer. -5520.3. What is the difference between the Emissions (in thousand metric tons of CO2 equivalent) in 1990 and Emissions (in thousand metric tons of CO2 equivalent) in 2000 in Ghana?
Keep it short and to the point. 448.2. What is the difference between the Emissions (in thousand metric tons of CO2 equivalent) of 1990 and Emissions (in thousand metric tons of CO2 equivalent) of 2005 in Ghana?
Make the answer very short. 581.5. What is the difference between the Emissions (in thousand metric tons of CO2 equivalent) of 1990 and Emissions (in thousand metric tons of CO2 equivalent) of 2008 in Ghana?
Offer a very short reply. 585. What is the difference between the Emissions (in thousand metric tons of CO2 equivalent) of 2000 and Emissions (in thousand metric tons of CO2 equivalent) of 2005 in Ghana?
Your answer should be compact. 133.3. What is the difference between the Emissions (in thousand metric tons of CO2 equivalent) of 2000 and Emissions (in thousand metric tons of CO2 equivalent) of 2008 in Ghana?
Your answer should be compact. 136.8. What is the ratio of the Emissions (in thousand metric tons of CO2 equivalent) of 1990 in Egypt, Arab Rep. to that in Estonia?
Keep it short and to the point. 976.43. What is the ratio of the Emissions (in thousand metric tons of CO2 equivalent) in 2000 in Egypt, Arab Rep. to that in Estonia?
Keep it short and to the point. 192.9. What is the ratio of the Emissions (in thousand metric tons of CO2 equivalent) of 2005 in Egypt, Arab Rep. to that in Estonia?
Provide a succinct answer. 80.96. What is the ratio of the Emissions (in thousand metric tons of CO2 equivalent) in 2008 in Egypt, Arab Rep. to that in Estonia?
Your answer should be very brief. 67.97. What is the ratio of the Emissions (in thousand metric tons of CO2 equivalent) of 1990 in Egypt, Arab Rep. to that in Finland?
Make the answer very short. 20.46. What is the ratio of the Emissions (in thousand metric tons of CO2 equivalent) of 2000 in Egypt, Arab Rep. to that in Finland?
Give a very brief answer. 4.92. What is the ratio of the Emissions (in thousand metric tons of CO2 equivalent) in 2005 in Egypt, Arab Rep. to that in Finland?
Make the answer very short. 3.88. What is the ratio of the Emissions (in thousand metric tons of CO2 equivalent) of 2008 in Egypt, Arab Rep. to that in Finland?
Your answer should be very brief. 3.36. What is the ratio of the Emissions (in thousand metric tons of CO2 equivalent) in 1990 in Egypt, Arab Rep. to that in France?
Give a very brief answer. 0.22. What is the ratio of the Emissions (in thousand metric tons of CO2 equivalent) in 2000 in Egypt, Arab Rep. to that in France?
Your answer should be compact. 0.2. What is the ratio of the Emissions (in thousand metric tons of CO2 equivalent) in 2005 in Egypt, Arab Rep. to that in France?
Provide a succinct answer. 0.21. What is the ratio of the Emissions (in thousand metric tons of CO2 equivalent) of 2008 in Egypt, Arab Rep. to that in France?
Your answer should be very brief. 0.19. What is the ratio of the Emissions (in thousand metric tons of CO2 equivalent) of 1990 in Egypt, Arab Rep. to that in Germany?
Keep it short and to the point. 0.16. What is the ratio of the Emissions (in thousand metric tons of CO2 equivalent) in 2000 in Egypt, Arab Rep. to that in Germany?
Your answer should be compact. 0.14. What is the ratio of the Emissions (in thousand metric tons of CO2 equivalent) of 2005 in Egypt, Arab Rep. to that in Germany?
Your answer should be very brief. 0.15. What is the ratio of the Emissions (in thousand metric tons of CO2 equivalent) in 2008 in Egypt, Arab Rep. to that in Germany?
Ensure brevity in your answer.  0.13. What is the ratio of the Emissions (in thousand metric tons of CO2 equivalent) of 1990 in Egypt, Arab Rep. to that in Ghana?
Offer a terse response. 3.44. What is the ratio of the Emissions (in thousand metric tons of CO2 equivalent) in 2000 in Egypt, Arab Rep. to that in Ghana?
Ensure brevity in your answer.  17.34. What is the ratio of the Emissions (in thousand metric tons of CO2 equivalent) in 2005 in Egypt, Arab Rep. to that in Ghana?
Give a very brief answer. 216.99. What is the ratio of the Emissions (in thousand metric tons of CO2 equivalent) in 2008 in Egypt, Arab Rep. to that in Ghana?
Give a very brief answer. 323.46. What is the ratio of the Emissions (in thousand metric tons of CO2 equivalent) of 1990 in Estonia to that in Finland?
Your answer should be compact. 0.02. What is the ratio of the Emissions (in thousand metric tons of CO2 equivalent) in 2000 in Estonia to that in Finland?
Your answer should be very brief. 0.03. What is the ratio of the Emissions (in thousand metric tons of CO2 equivalent) of 2005 in Estonia to that in Finland?
Ensure brevity in your answer.  0.05. What is the ratio of the Emissions (in thousand metric tons of CO2 equivalent) of 2008 in Estonia to that in Finland?
Make the answer very short. 0.05. What is the ratio of the Emissions (in thousand metric tons of CO2 equivalent) of 1990 in Estonia to that in France?
Ensure brevity in your answer.  0. What is the ratio of the Emissions (in thousand metric tons of CO2 equivalent) in 2005 in Estonia to that in France?
Your answer should be very brief. 0. What is the ratio of the Emissions (in thousand metric tons of CO2 equivalent) in 2008 in Estonia to that in France?
Your response must be concise. 0. What is the ratio of the Emissions (in thousand metric tons of CO2 equivalent) of 2000 in Estonia to that in Germany?
Offer a terse response. 0. What is the ratio of the Emissions (in thousand metric tons of CO2 equivalent) in 2005 in Estonia to that in Germany?
Provide a succinct answer. 0. What is the ratio of the Emissions (in thousand metric tons of CO2 equivalent) in 2008 in Estonia to that in Germany?
Offer a very short reply. 0. What is the ratio of the Emissions (in thousand metric tons of CO2 equivalent) in 1990 in Estonia to that in Ghana?
Offer a very short reply. 0. What is the ratio of the Emissions (in thousand metric tons of CO2 equivalent) of 2000 in Estonia to that in Ghana?
Provide a succinct answer. 0.09. What is the ratio of the Emissions (in thousand metric tons of CO2 equivalent) of 2005 in Estonia to that in Ghana?
Ensure brevity in your answer.  2.68. What is the ratio of the Emissions (in thousand metric tons of CO2 equivalent) in 2008 in Estonia to that in Ghana?
Offer a very short reply. 4.76. What is the ratio of the Emissions (in thousand metric tons of CO2 equivalent) in 1990 in Finland to that in France?
Keep it short and to the point. 0.01. What is the ratio of the Emissions (in thousand metric tons of CO2 equivalent) in 2000 in Finland to that in France?
Offer a terse response. 0.04. What is the ratio of the Emissions (in thousand metric tons of CO2 equivalent) in 2005 in Finland to that in France?
Your response must be concise. 0.05. What is the ratio of the Emissions (in thousand metric tons of CO2 equivalent) of 2008 in Finland to that in France?
Provide a short and direct response. 0.06. What is the ratio of the Emissions (in thousand metric tons of CO2 equivalent) of 1990 in Finland to that in Germany?
Keep it short and to the point. 0.01. What is the ratio of the Emissions (in thousand metric tons of CO2 equivalent) of 2000 in Finland to that in Germany?
Make the answer very short. 0.03. What is the ratio of the Emissions (in thousand metric tons of CO2 equivalent) in 2005 in Finland to that in Germany?
Offer a terse response. 0.04. What is the ratio of the Emissions (in thousand metric tons of CO2 equivalent) in 2008 in Finland to that in Germany?
Ensure brevity in your answer.  0.04. What is the ratio of the Emissions (in thousand metric tons of CO2 equivalent) of 1990 in Finland to that in Ghana?
Your answer should be compact. 0.17. What is the ratio of the Emissions (in thousand metric tons of CO2 equivalent) of 2000 in Finland to that in Ghana?
Provide a short and direct response. 3.53. What is the ratio of the Emissions (in thousand metric tons of CO2 equivalent) in 2005 in Finland to that in Ghana?
Provide a short and direct response. 55.95. What is the ratio of the Emissions (in thousand metric tons of CO2 equivalent) of 2008 in Finland to that in Ghana?
Your response must be concise. 96.38. What is the ratio of the Emissions (in thousand metric tons of CO2 equivalent) in 1990 in France to that in Germany?
Your response must be concise. 0.75. What is the ratio of the Emissions (in thousand metric tons of CO2 equivalent) in 2000 in France to that in Germany?
Offer a very short reply. 0.7. What is the ratio of the Emissions (in thousand metric tons of CO2 equivalent) of 2005 in France to that in Germany?
Your answer should be compact. 0.7. What is the ratio of the Emissions (in thousand metric tons of CO2 equivalent) in 2008 in France to that in Germany?
Make the answer very short. 0.71. What is the ratio of the Emissions (in thousand metric tons of CO2 equivalent) of 1990 in France to that in Ghana?
Give a very brief answer. 15.88. What is the ratio of the Emissions (in thousand metric tons of CO2 equivalent) in 2000 in France to that in Ghana?
Provide a succinct answer. 87.64. What is the ratio of the Emissions (in thousand metric tons of CO2 equivalent) of 2005 in France to that in Ghana?
Your answer should be very brief. 1023.07. What is the ratio of the Emissions (in thousand metric tons of CO2 equivalent) in 2008 in France to that in Ghana?
Provide a short and direct response. 1714.73. What is the ratio of the Emissions (in thousand metric tons of CO2 equivalent) in 1990 in Germany to that in Ghana?
Provide a succinct answer. 21.04. What is the ratio of the Emissions (in thousand metric tons of CO2 equivalent) of 2000 in Germany to that in Ghana?
Give a very brief answer. 125.09. What is the ratio of the Emissions (in thousand metric tons of CO2 equivalent) of 2005 in Germany to that in Ghana?
Provide a short and direct response. 1463.78. What is the ratio of the Emissions (in thousand metric tons of CO2 equivalent) of 2008 in Germany to that in Ghana?
Offer a terse response. 2414.09. What is the difference between the highest and the second highest Emissions (in thousand metric tons of CO2 equivalent) in 1990?
Your response must be concise. 3077.5. What is the difference between the highest and the second highest Emissions (in thousand metric tons of CO2 equivalent) of 2000?
Provide a succinct answer. 5542.7. What is the difference between the highest and the second highest Emissions (in thousand metric tons of CO2 equivalent) in 2005?
Provide a succinct answer. 6478.3. What is the difference between the highest and the second highest Emissions (in thousand metric tons of CO2 equivalent) in 2008?
Your answer should be compact. 7832.8. What is the difference between the highest and the lowest Emissions (in thousand metric tons of CO2 equivalent) in 1990?
Offer a terse response. 1.25e+04. What is the difference between the highest and the lowest Emissions (in thousand metric tons of CO2 equivalent) in 2000?
Your answer should be compact. 1.85e+04. What is the difference between the highest and the lowest Emissions (in thousand metric tons of CO2 equivalent) of 2005?
Offer a terse response. 2.15e+04. What is the difference between the highest and the lowest Emissions (in thousand metric tons of CO2 equivalent) in 2008?
Make the answer very short. 2.70e+04. 